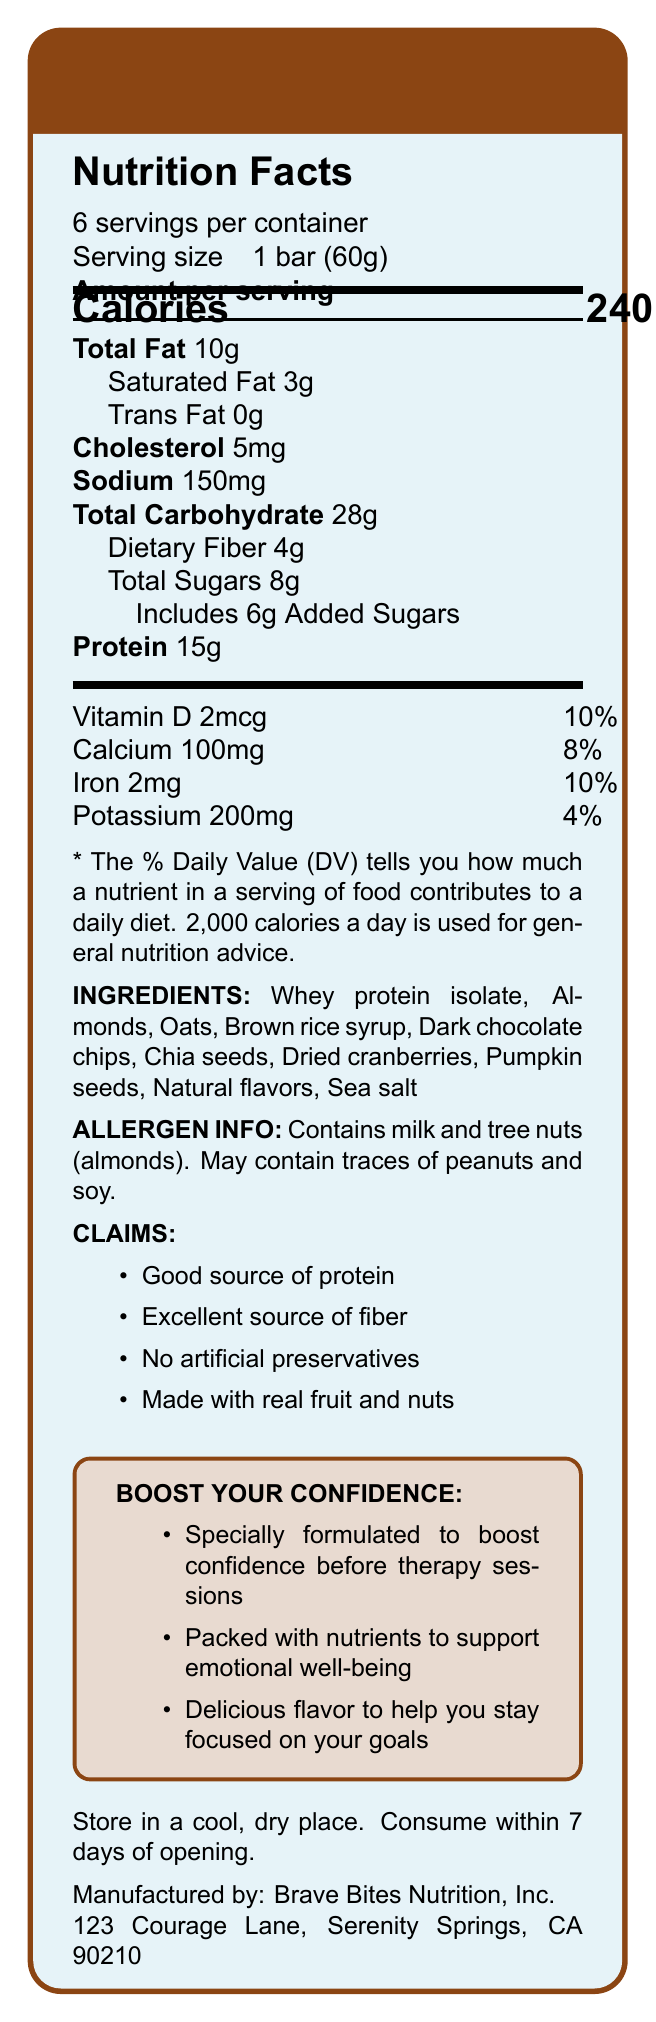What is the serving size of the Equine Courage Crunch Bar? The serving size is directly listed under the "Nutrition Facts" title in the document.
Answer: 1 bar (60g) How many servings are there per container? The number of servings per container is indicated just below the product name and serving size.
Answer: 6 How many calories does one serving of the Equine Courage Crunch Bar contain? The calorie count per serving is mentioned in the "Amount per serving" section, specifically in a bold large font.
Answer: 240 What percentage of the daily value of protein is provided by one bar? The daily value percentage for protein is listed next to the protein amount in the nutrition facts section.
Answer: 30% What are the total grams of sugars in one bar, and how much of it is added sugars? The total sugars and added sugars are listed under the Total Carbohydrate section of the nutrition facts.
Answer: 8g total sugars, 6g added sugars What allergens are present in the Equine Courage Crunch Bar? This information is explicitly mentioned in the "Allergen Info" section of the document.
Answer: Milk and tree nuts (almonds) What is the main ingredient in the Equine Courage Crunch Bar? The ingredients are listed in order of predominance, and "Whey protein isolate" is the first item listed.
Answer: Whey protein isolate How many milligrams of sodium are in one serving of the Equine Courage Crunch Bar? The sodium content per serving is listed under the "Amount per serving" section in the nutrition facts.
Answer: 150mg Which of the following claims is NOT made about the Equine Courage Crunch Bar? 
A. Good source of protein 
B. Low in sugar 
C. No artificial preservatives
D. Made with real fruit and nuts The document lists the claims for the bar, and "Low in sugar" is not one of them.
Answer: B. Low in sugar What is the amount of dietary fiber in one bar, and what percentage of the daily value does this represent? The amount of dietary fiber and its daily value percentage are listed under the Total Carbohydrate section.
Answer: 4g, 14% Is the Equine Courage Crunch Bar appropriate for someone with a peanut allergy? The Allergen Info section states that the bar may contain traces of peanuts.
Answer: No What is the company that manufactures the Equine Courage Crunch Bar? 
1. NutriBites Inc.
2. Brave Bites Nutrition, Inc.
3. Courage Nutrition Co.
4. Serenity Snacks LLC The manufacturer's name is listed at the end of the document.
Answer: 2. Brave Bites Nutrition, Inc. Where is Brave Bites Nutrition, Inc. located? The address of the manufacturer is provided at the end of the document.
Answer: 123 Courage Lane, Serenity Springs, CA 90210 Can you determine the specific type of therapy sessions mentioned in the document? The document states that the bar is formulated to boost confidence before therapy sessions but does not specify the type of therapy sessions.
Answer: Not enough information Summarize the key nutrition and marketing points about the Equine Courage Crunch Bar. This summary captures the essential nutrition facts and marketing statements provided in the document, covering ingredients, nutritional benefits, and intended use.
Answer: The Equine Courage Crunch Bar is a protein-rich energy bar with 15g of protein, 10g of total fat, and 4g of dietary fiber per serving. Each bar contains 240 calories and claims to be an excellent source of fiber and protein, with no artificial preservatives and real fruit and nuts. It is marketed as a confidence booster before therapy sessions and to support emotional well-being. 